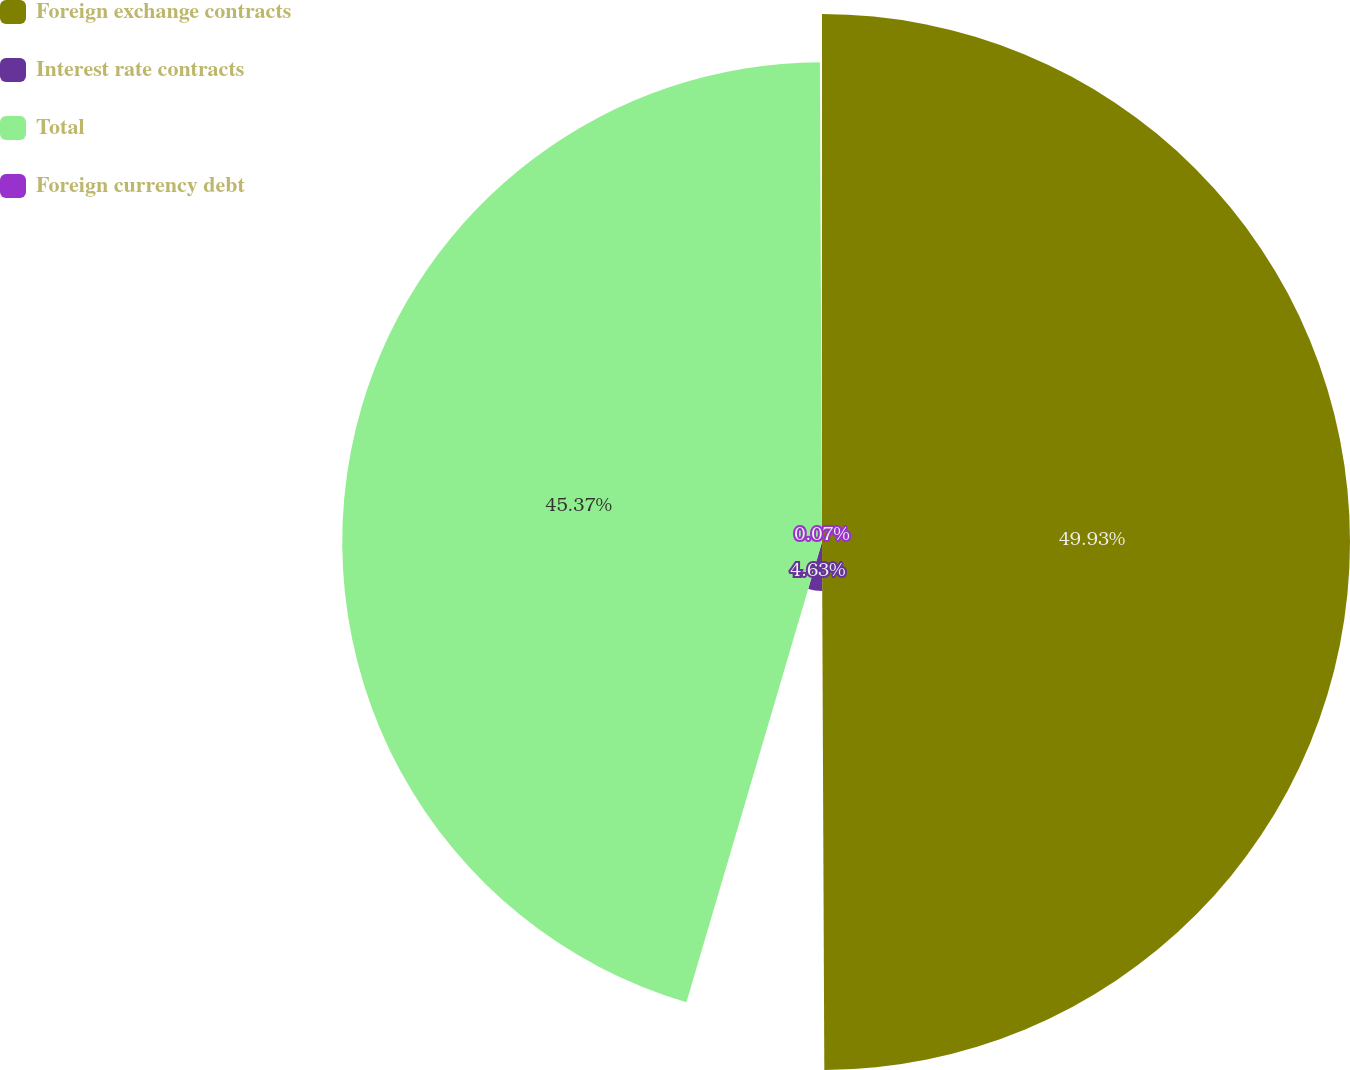Convert chart. <chart><loc_0><loc_0><loc_500><loc_500><pie_chart><fcel>Foreign exchange contracts<fcel>Interest rate contracts<fcel>Total<fcel>Foreign currency debt<nl><fcel>49.93%<fcel>4.63%<fcel>45.37%<fcel>0.07%<nl></chart> 